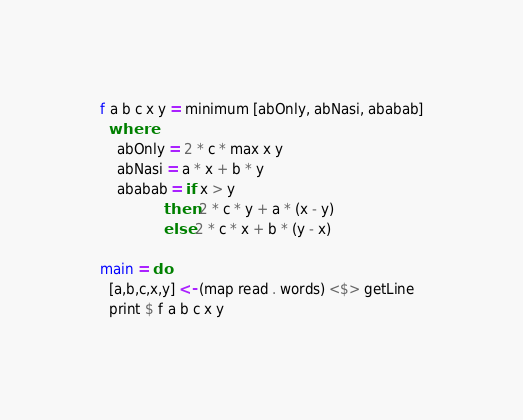Convert code to text. <code><loc_0><loc_0><loc_500><loc_500><_Haskell_>f a b c x y = minimum [abOnly, abNasi, ababab]
  where
    abOnly = 2 * c * max x y
    abNasi = a * x + b * y
    ababab = if x > y
               then 2 * c * y + a * (x - y)
               else 2 * c * x + b * (y - x)

main = do
  [a,b,c,x,y] <- (map read . words) <$> getLine
  print $ f a b c x y
</code> 